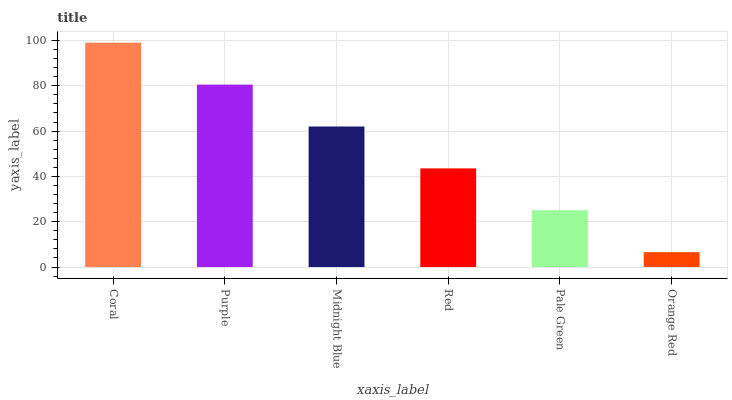Is Orange Red the minimum?
Answer yes or no. Yes. Is Coral the maximum?
Answer yes or no. Yes. Is Purple the minimum?
Answer yes or no. No. Is Purple the maximum?
Answer yes or no. No. Is Coral greater than Purple?
Answer yes or no. Yes. Is Purple less than Coral?
Answer yes or no. Yes. Is Purple greater than Coral?
Answer yes or no. No. Is Coral less than Purple?
Answer yes or no. No. Is Midnight Blue the high median?
Answer yes or no. Yes. Is Red the low median?
Answer yes or no. Yes. Is Pale Green the high median?
Answer yes or no. No. Is Pale Green the low median?
Answer yes or no. No. 